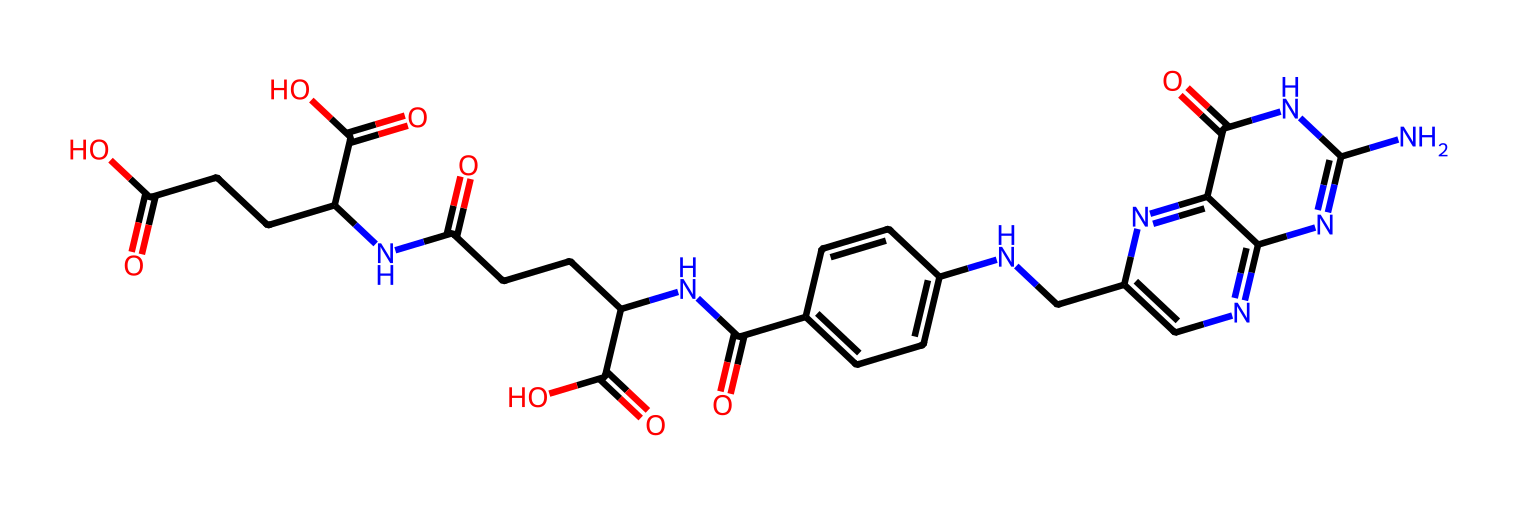What is the name of this chemical? The SMILES representation indicates that the chemical is folic acid, a vital nutrient essential for fetal development and cellular division.
Answer: folic acid How many nitrogen atoms are present in this chemical? By examining the SMILES, there are four nitrogen atoms (N) visualized in various functional groups throughout the structure.
Answer: four What type of chemical structure does folic acid primarily have? Folic acid has a bicyclic structure along with a pteridine ring, which is common in many vitamins such as B9.
Answer: bicyclic structure What functional groups are present in this molecule? The SMILES reveals carboxylic acid (–COOH) and amide (–CONH) functional groups, which are characteristic of folic acid.
Answer: carboxylic acid, amide How many carboxylic acid groups are in this chemical? A careful count in the structure shows that there are three carboxylic acid groups present in folic acid.
Answer: three 